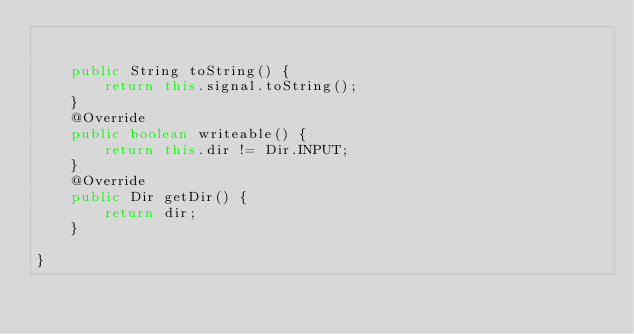Convert code to text. <code><loc_0><loc_0><loc_500><loc_500><_Java_>
	
	public String toString() {
		return this.signal.toString();
	}
	@Override
	public boolean writeable() {
		return this.dir != Dir.INPUT; 
	}
	@Override
	public Dir getDir() {
		return dir;
	}

}
</code> 